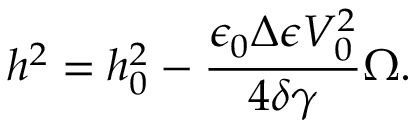Convert formula to latex. <formula><loc_0><loc_0><loc_500><loc_500>h ^ { 2 } = h _ { 0 } ^ { 2 } - \frac { \epsilon _ { 0 } \Delta \epsilon V _ { 0 } ^ { 2 } } { 4 \delta \gamma } \Omega .</formula> 